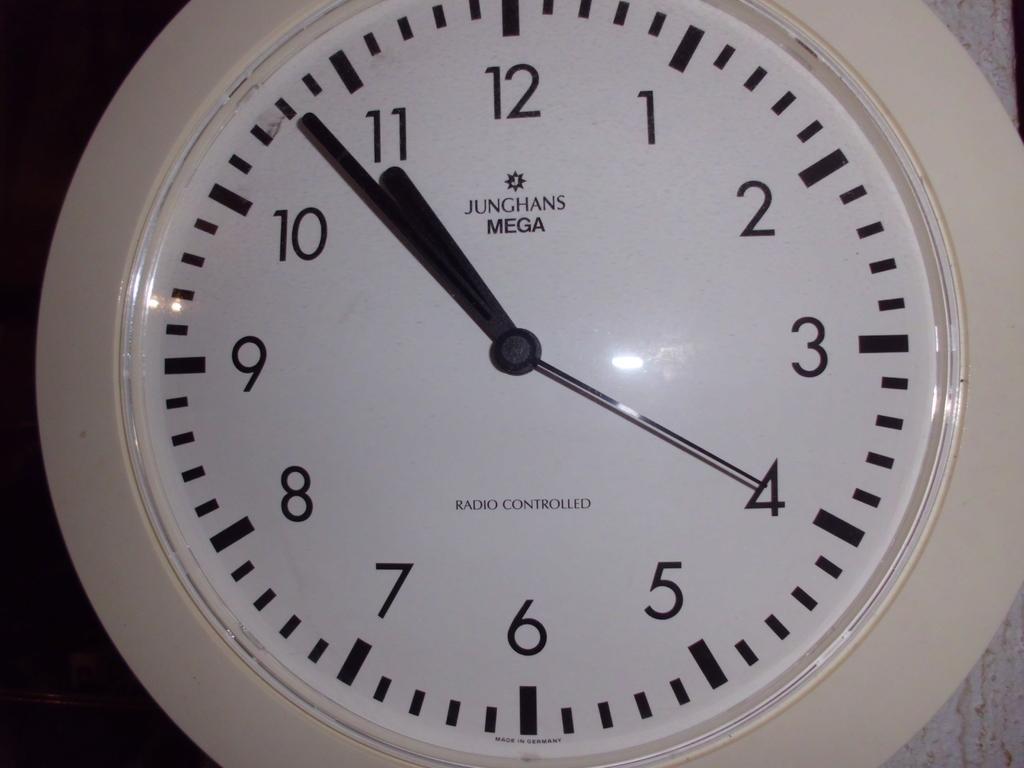<image>
Relay a brief, clear account of the picture shown. A white analouge clock with black hands and numbers at 10:50. 